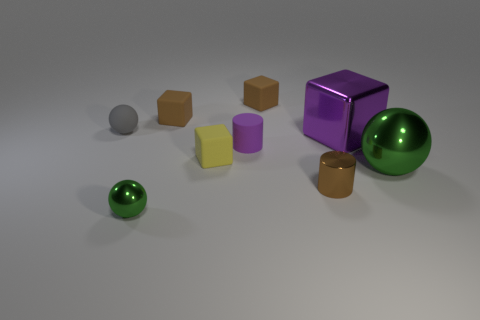There is a metal thing behind the shiny sphere that is on the right side of the big thing behind the big green ball; what is its size?
Offer a terse response. Large. Do the large green thing and the small brown matte object that is to the right of the small yellow object have the same shape?
Make the answer very short. No. What number of other things are there of the same size as the metal cylinder?
Give a very brief answer. 6. There is a metallic sphere that is on the left side of the small yellow rubber thing; how big is it?
Give a very brief answer. Small. How many tiny gray spheres have the same material as the small yellow cube?
Keep it short and to the point. 1. There is a brown object in front of the matte sphere; is its shape the same as the small purple matte object?
Your response must be concise. Yes. The small brown thing that is in front of the small rubber sphere has what shape?
Your answer should be very brief. Cylinder. There is a cylinder that is the same color as the shiny block; what is its size?
Your answer should be compact. Small. What material is the large green sphere?
Give a very brief answer. Metal. What is the color of the metal ball that is the same size as the gray object?
Offer a very short reply. Green. 